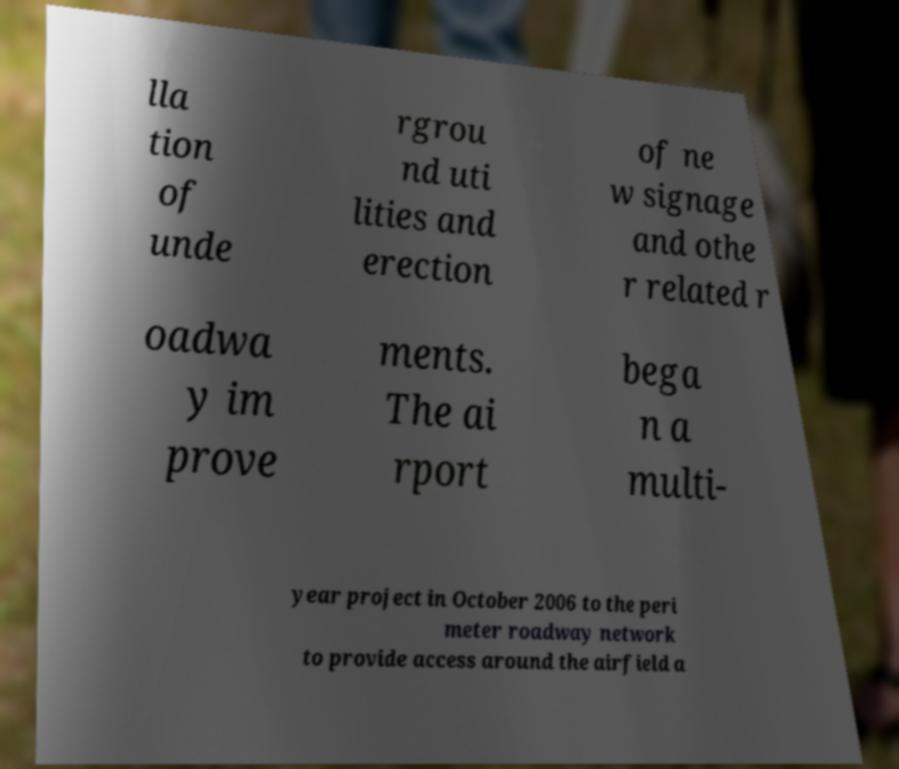Could you extract and type out the text from this image? lla tion of unde rgrou nd uti lities and erection of ne w signage and othe r related r oadwa y im prove ments. The ai rport bega n a multi- year project in October 2006 to the peri meter roadway network to provide access around the airfield a 